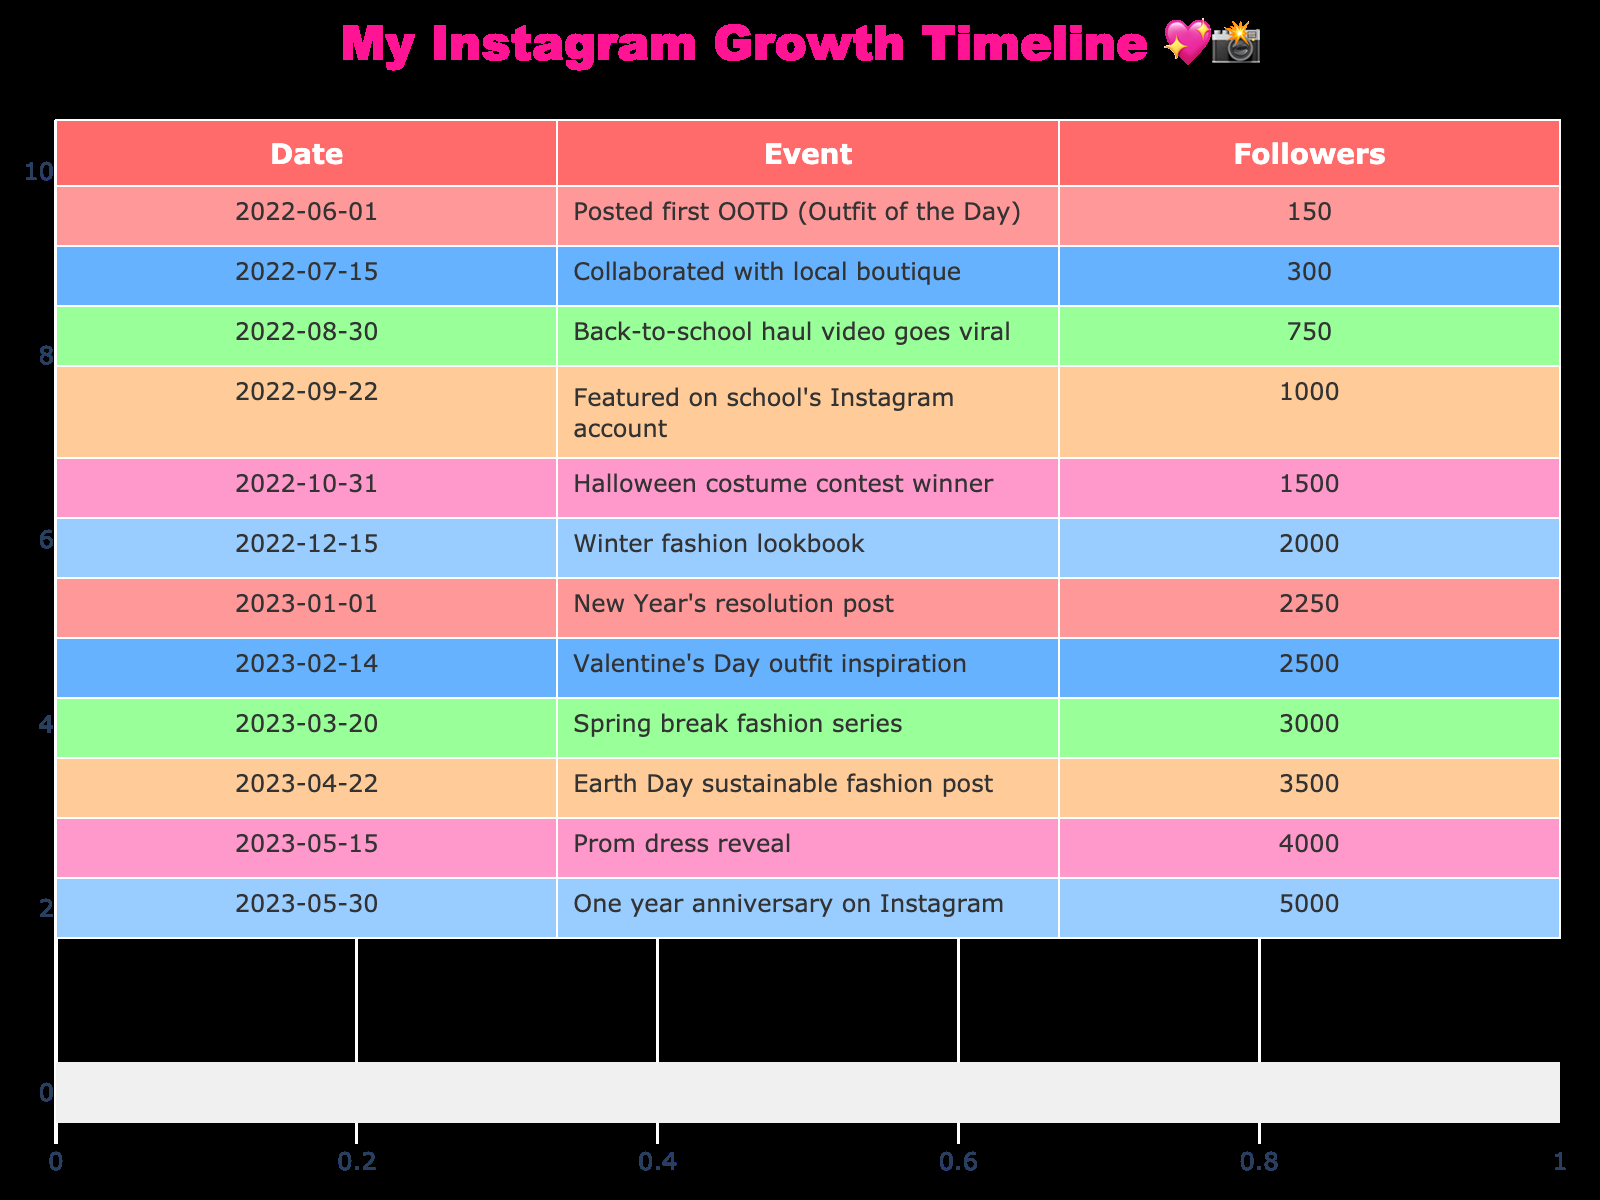What was the total follower count increase from June 1, 2022, to May 30, 2023? The follower count on June 1, 2022, was 150, and on May 30, 2023, it was 5000. To find the total increase, subtract the initial count from the final count: 5000 - 150 = 4850.
Answer: 4850 Which event led to the most significant increase in followers? The event with the highest increase in followers is "Back-to-school haul video goes viral," which increased followers from 300 to 750. This is an increase of 450 followers, the largest single jump shown in the table.
Answer: Back-to-school haul video goes viral On which date did the follower count reach 2000? By checking the table, I see that the event 'Winter fashion lookbook' on December 15, 2022, corresponds to the follower count reaching 2000.
Answer: December 15, 2022 Was the follower count ever below 1500 after October 31, 2022? Looking at the table, the follower counts for events after October 31, 2022, start at 1500 and increases thereafter. Therefore, the answer is no; it never fell below 1500 after that date.
Answer: No What is the average follower count across all the listed events? To find the average, we first sum up all the follower counts: 150 + 300 + 750 + 1000 + 1500 + 2000 + 2250 + 2500 + 3000 + 3500 + 4000 + 5000 = 20700. There are 12 events, so the average is 20700 / 12 = 1725.
Answer: 1725 What was the percentage growth of followers from the first event to the last event? The first event had 150 followers, and the last event had 5000 followers. The growth is calculated as: ((5000 - 150) / 150) * 100 = (4850 / 150) * 100 = 3233.33%.
Answer: 3233.33% How many events had a follower count of over 3000? By examining the table, I see that there are four events with follower counts over 3000: 'Spring break fashion series' (3000), 'Earth Day sustainable fashion post' (3500), 'Prom dress reveal' (4000), and 'One year anniversary on Instagram' (5000). Therefore, the total is four events.
Answer: 4 Which month had the most posts in the timeline? Observing the table, we see that the events are spread across multiple months but the most events occurred in May 2023 (with two events: 'Prom dress reveal' and 'One year anniversary on Instagram'). There are no other months with more than one event.
Answer: May 2023 